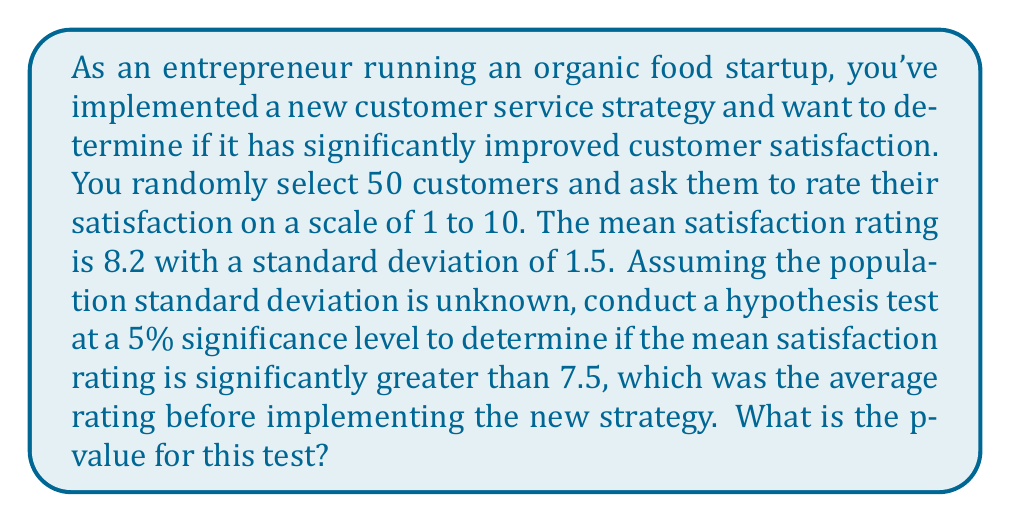Help me with this question. To solve this problem, we'll follow these steps:

1) First, let's state our hypotheses:
   $H_0: \mu \leq 7.5$ (null hypothesis)
   $H_a: \mu > 7.5$ (alternative hypothesis)

2) We're given:
   - Sample size: $n = 50$
   - Sample mean: $\bar{x} = 8.2$
   - Sample standard deviation: $s = 1.5$
   - Hypothesized population mean: $\mu_0 = 7.5$
   - Significance level: $\alpha = 0.05$

3) Since the population standard deviation is unknown and our sample size is less than 30, we'll use a t-test.

4) Calculate the t-statistic:
   $$t = \frac{\bar{x} - \mu_0}{s/\sqrt{n}} = \frac{8.2 - 7.5}{1.5/\sqrt{50}} = \frac{0.7}{0.2121} = 3.3$

5) Determine the degrees of freedom:
   $df = n - 1 = 50 - 1 = 49$

6) Find the p-value:
   The p-value is the probability of obtaining a t-statistic as extreme as or more extreme than the observed value, assuming the null hypothesis is true.

   For a one-tailed test with $t = 3.3$ and $df = 49$, we can use a t-distribution calculator or table to find the p-value.

   Using a t-distribution calculator, we find that the p-value is approximately 0.0009.

7) Interpret the results:
   Since the p-value (0.0009) is less than the significance level (0.05), we reject the null hypothesis.
Answer: The p-value for this hypothesis test is approximately 0.0009. 